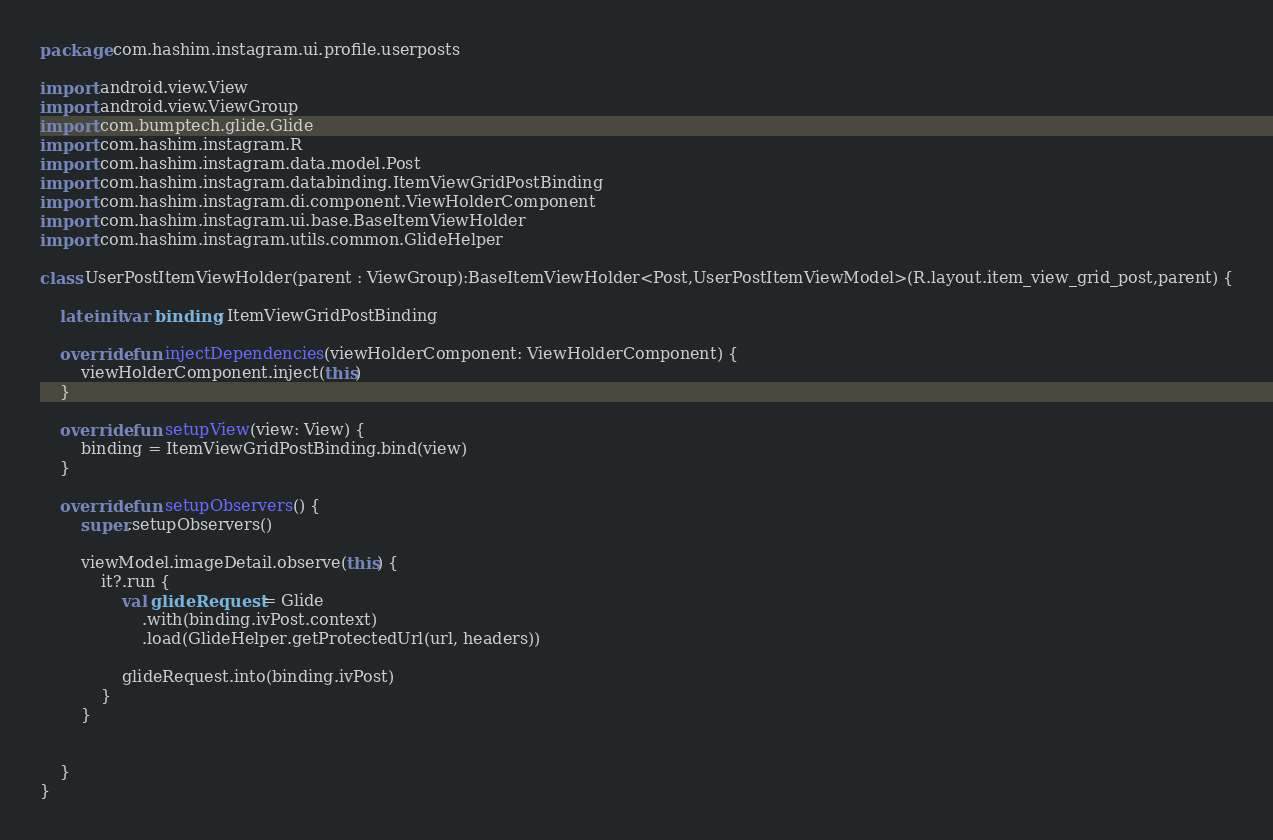Convert code to text. <code><loc_0><loc_0><loc_500><loc_500><_Kotlin_>package com.hashim.instagram.ui.profile.userposts

import android.view.View
import android.view.ViewGroup
import com.bumptech.glide.Glide
import com.hashim.instagram.R
import com.hashim.instagram.data.model.Post
import com.hashim.instagram.databinding.ItemViewGridPostBinding
import com.hashim.instagram.di.component.ViewHolderComponent
import com.hashim.instagram.ui.base.BaseItemViewHolder
import com.hashim.instagram.utils.common.GlideHelper

class UserPostItemViewHolder(parent : ViewGroup):BaseItemViewHolder<Post,UserPostItemViewModel>(R.layout.item_view_grid_post,parent) {

    lateinit var binding: ItemViewGridPostBinding

    override fun injectDependencies(viewHolderComponent: ViewHolderComponent) {
        viewHolderComponent.inject(this)
    }

    override fun setupView(view: View) {
        binding = ItemViewGridPostBinding.bind(view)
    }

    override fun setupObservers() {
        super.setupObservers()

        viewModel.imageDetail.observe(this) {
            it?.run {
                val glideRequest = Glide
                    .with(binding.ivPost.context)
                    .load(GlideHelper.getProtectedUrl(url, headers))

                glideRequest.into(binding.ivPost)
            }
        }


    }
}</code> 